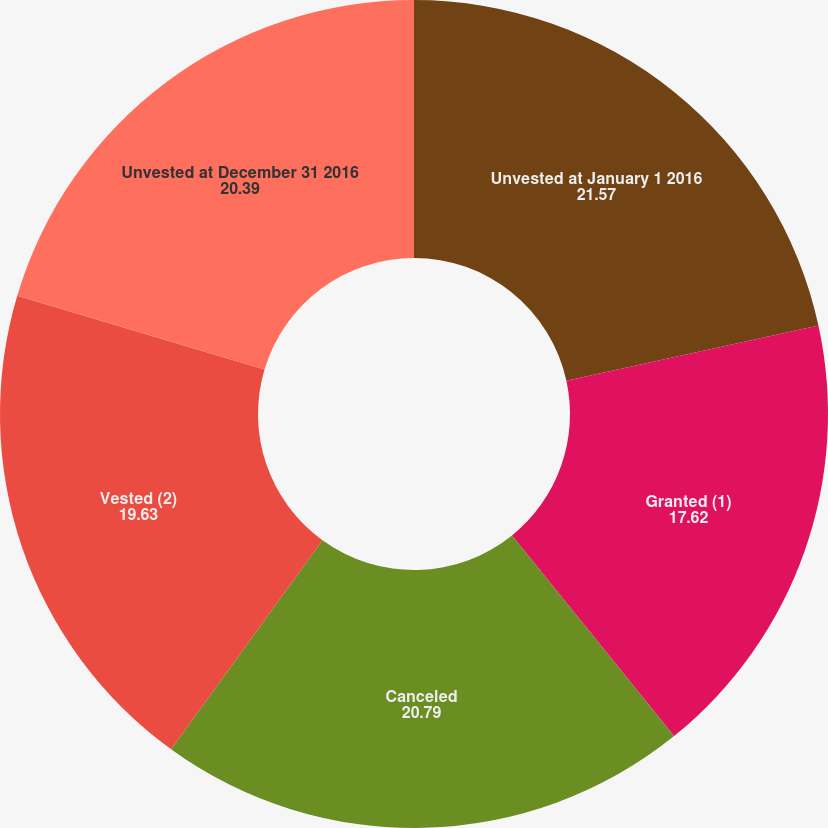<chart> <loc_0><loc_0><loc_500><loc_500><pie_chart><fcel>Unvested at January 1 2016<fcel>Granted (1)<fcel>Canceled<fcel>Vested (2)<fcel>Unvested at December 31 2016<nl><fcel>21.57%<fcel>17.62%<fcel>20.79%<fcel>19.63%<fcel>20.39%<nl></chart> 